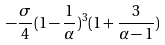<formula> <loc_0><loc_0><loc_500><loc_500>- \frac { \sigma } { 4 } ( 1 - \frac { 1 } { \alpha } ) ^ { 3 } ( 1 + \frac { 3 } { \alpha - 1 } )</formula> 